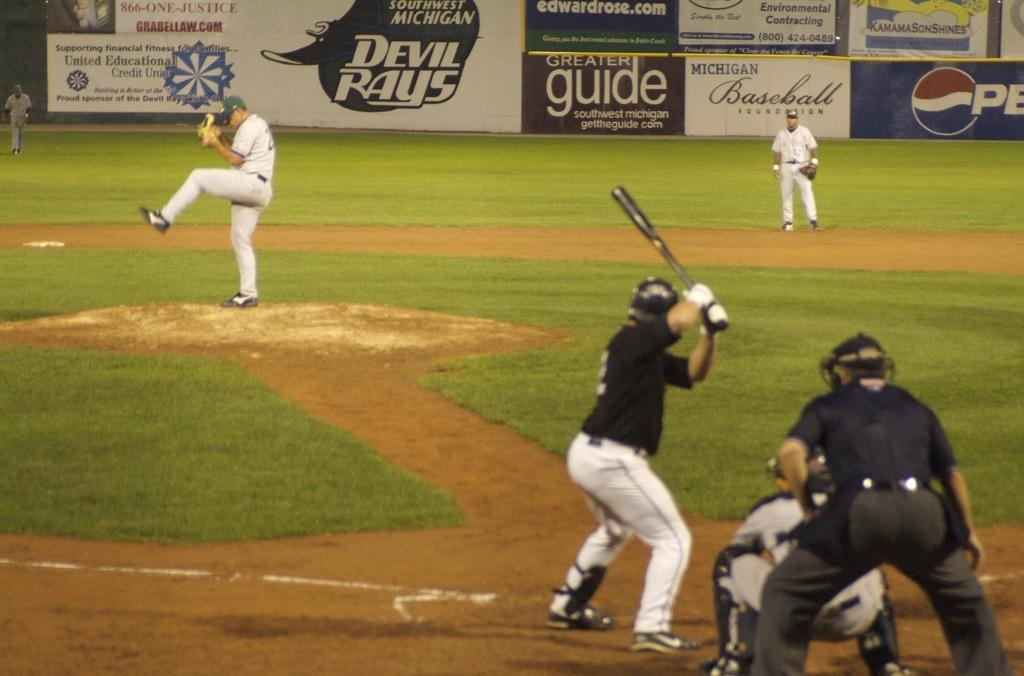<image>
Render a clear and concise summary of the photo. one of the sponsors of the game is Pepsi 